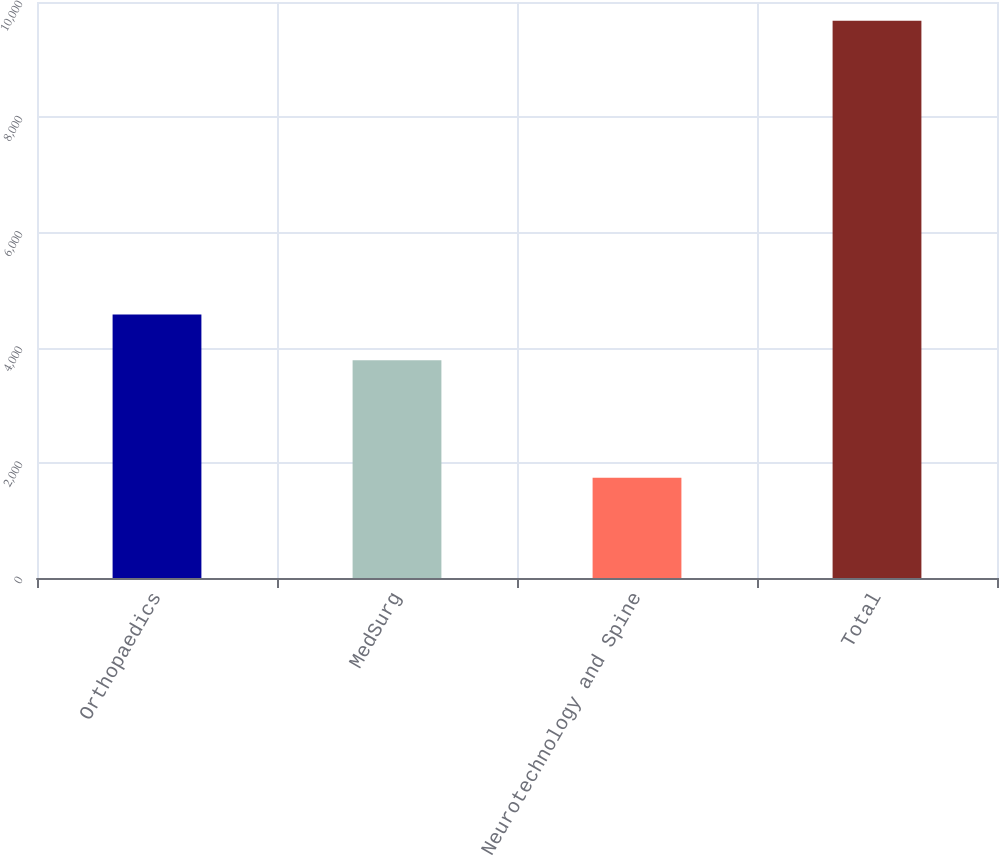<chart> <loc_0><loc_0><loc_500><loc_500><bar_chart><fcel>Orthopaedics<fcel>MedSurg<fcel>Neurotechnology and Spine<fcel>Total<nl><fcel>4574.4<fcel>3781<fcel>1741<fcel>9675<nl></chart> 